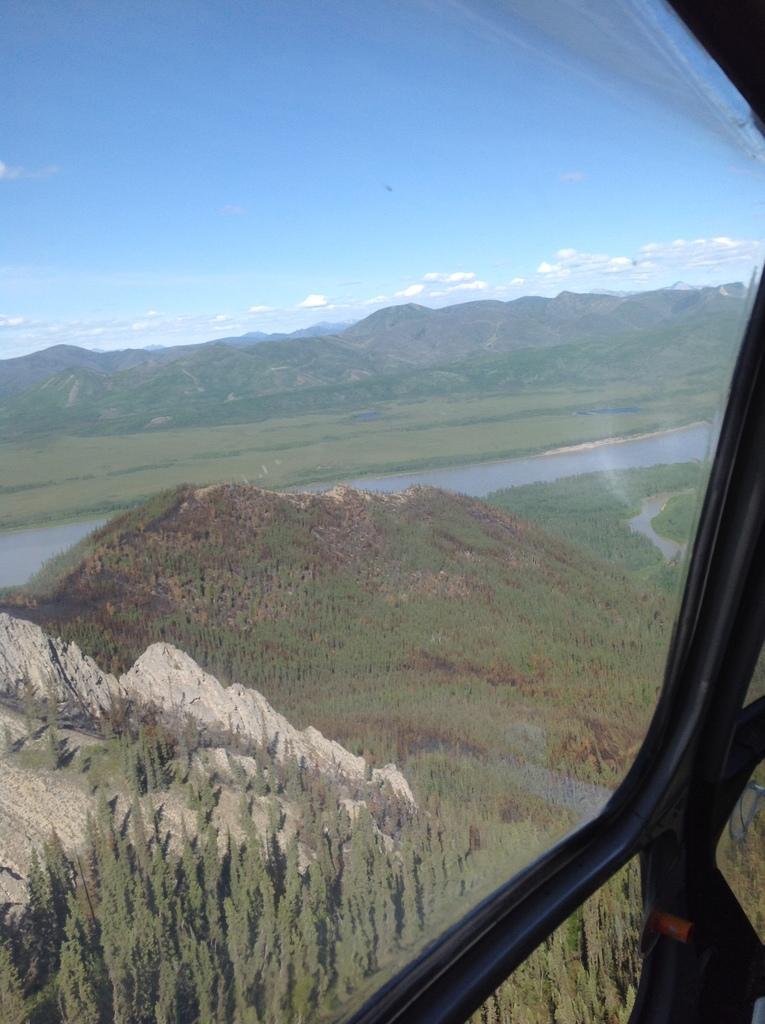Can you describe this image briefly? This image is taken from a helicopter, in this image there are mountain trees, river and the sky. 